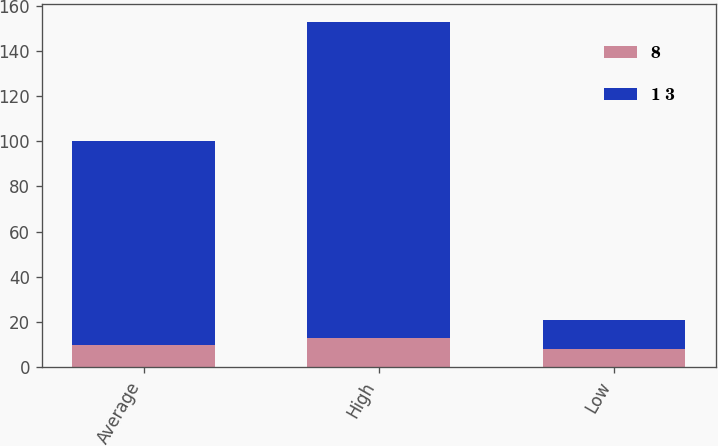Convert chart. <chart><loc_0><loc_0><loc_500><loc_500><stacked_bar_chart><ecel><fcel>Average<fcel>High<fcel>Low<nl><fcel>8<fcel>10<fcel>13<fcel>8<nl><fcel>1 3<fcel>90<fcel>140<fcel>13<nl></chart> 